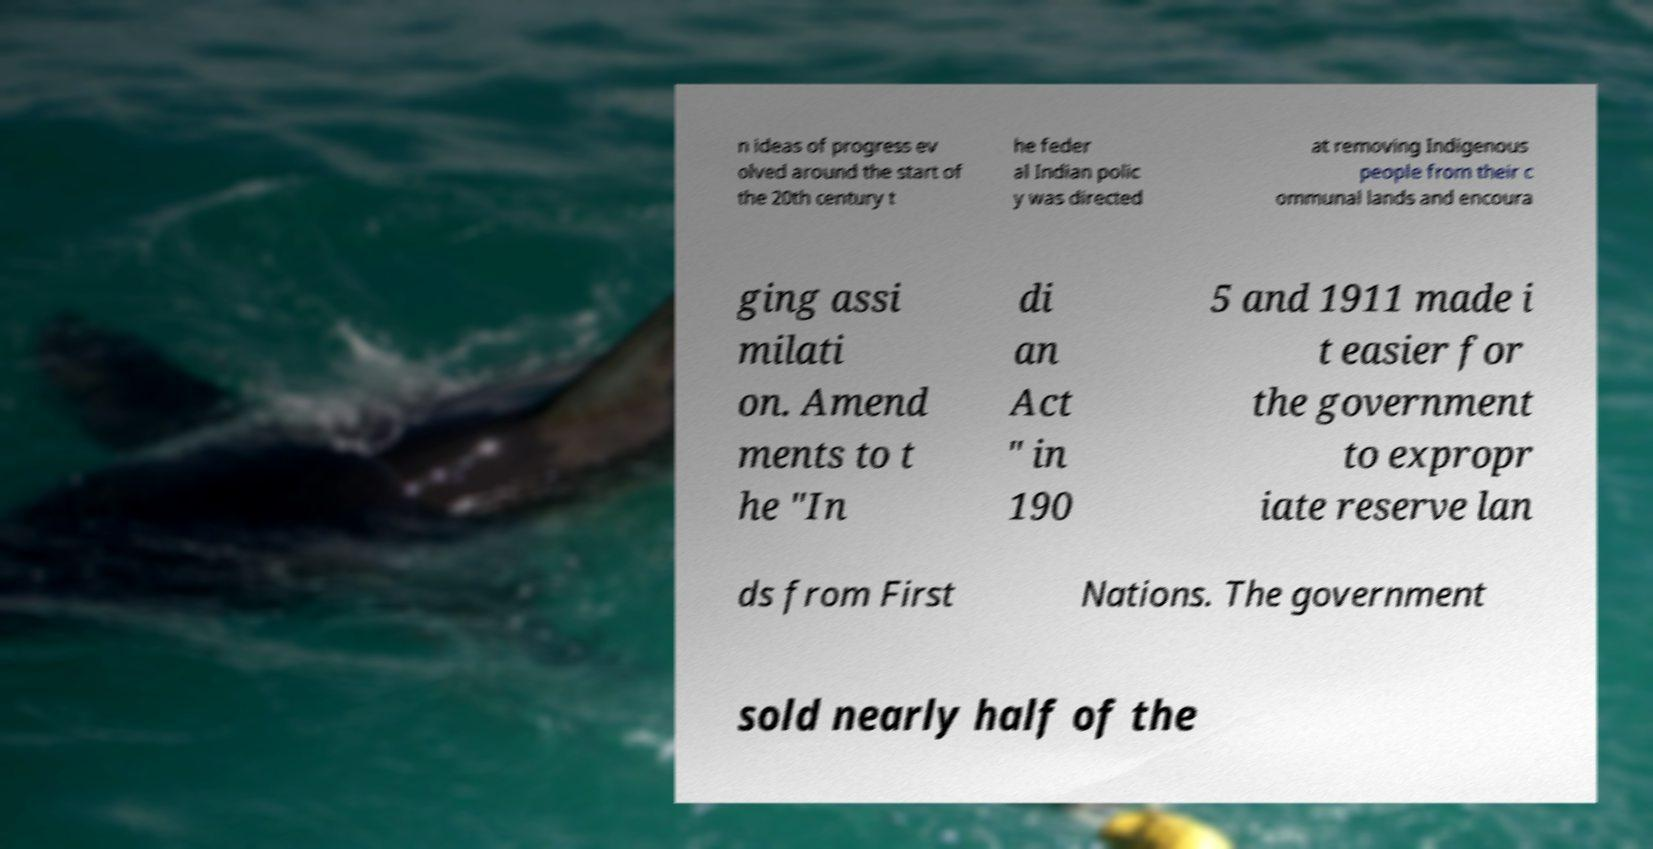Could you assist in decoding the text presented in this image and type it out clearly? n ideas of progress ev olved around the start of the 20th century t he feder al Indian polic y was directed at removing Indigenous people from their c ommunal lands and encoura ging assi milati on. Amend ments to t he "In di an Act " in 190 5 and 1911 made i t easier for the government to expropr iate reserve lan ds from First Nations. The government sold nearly half of the 